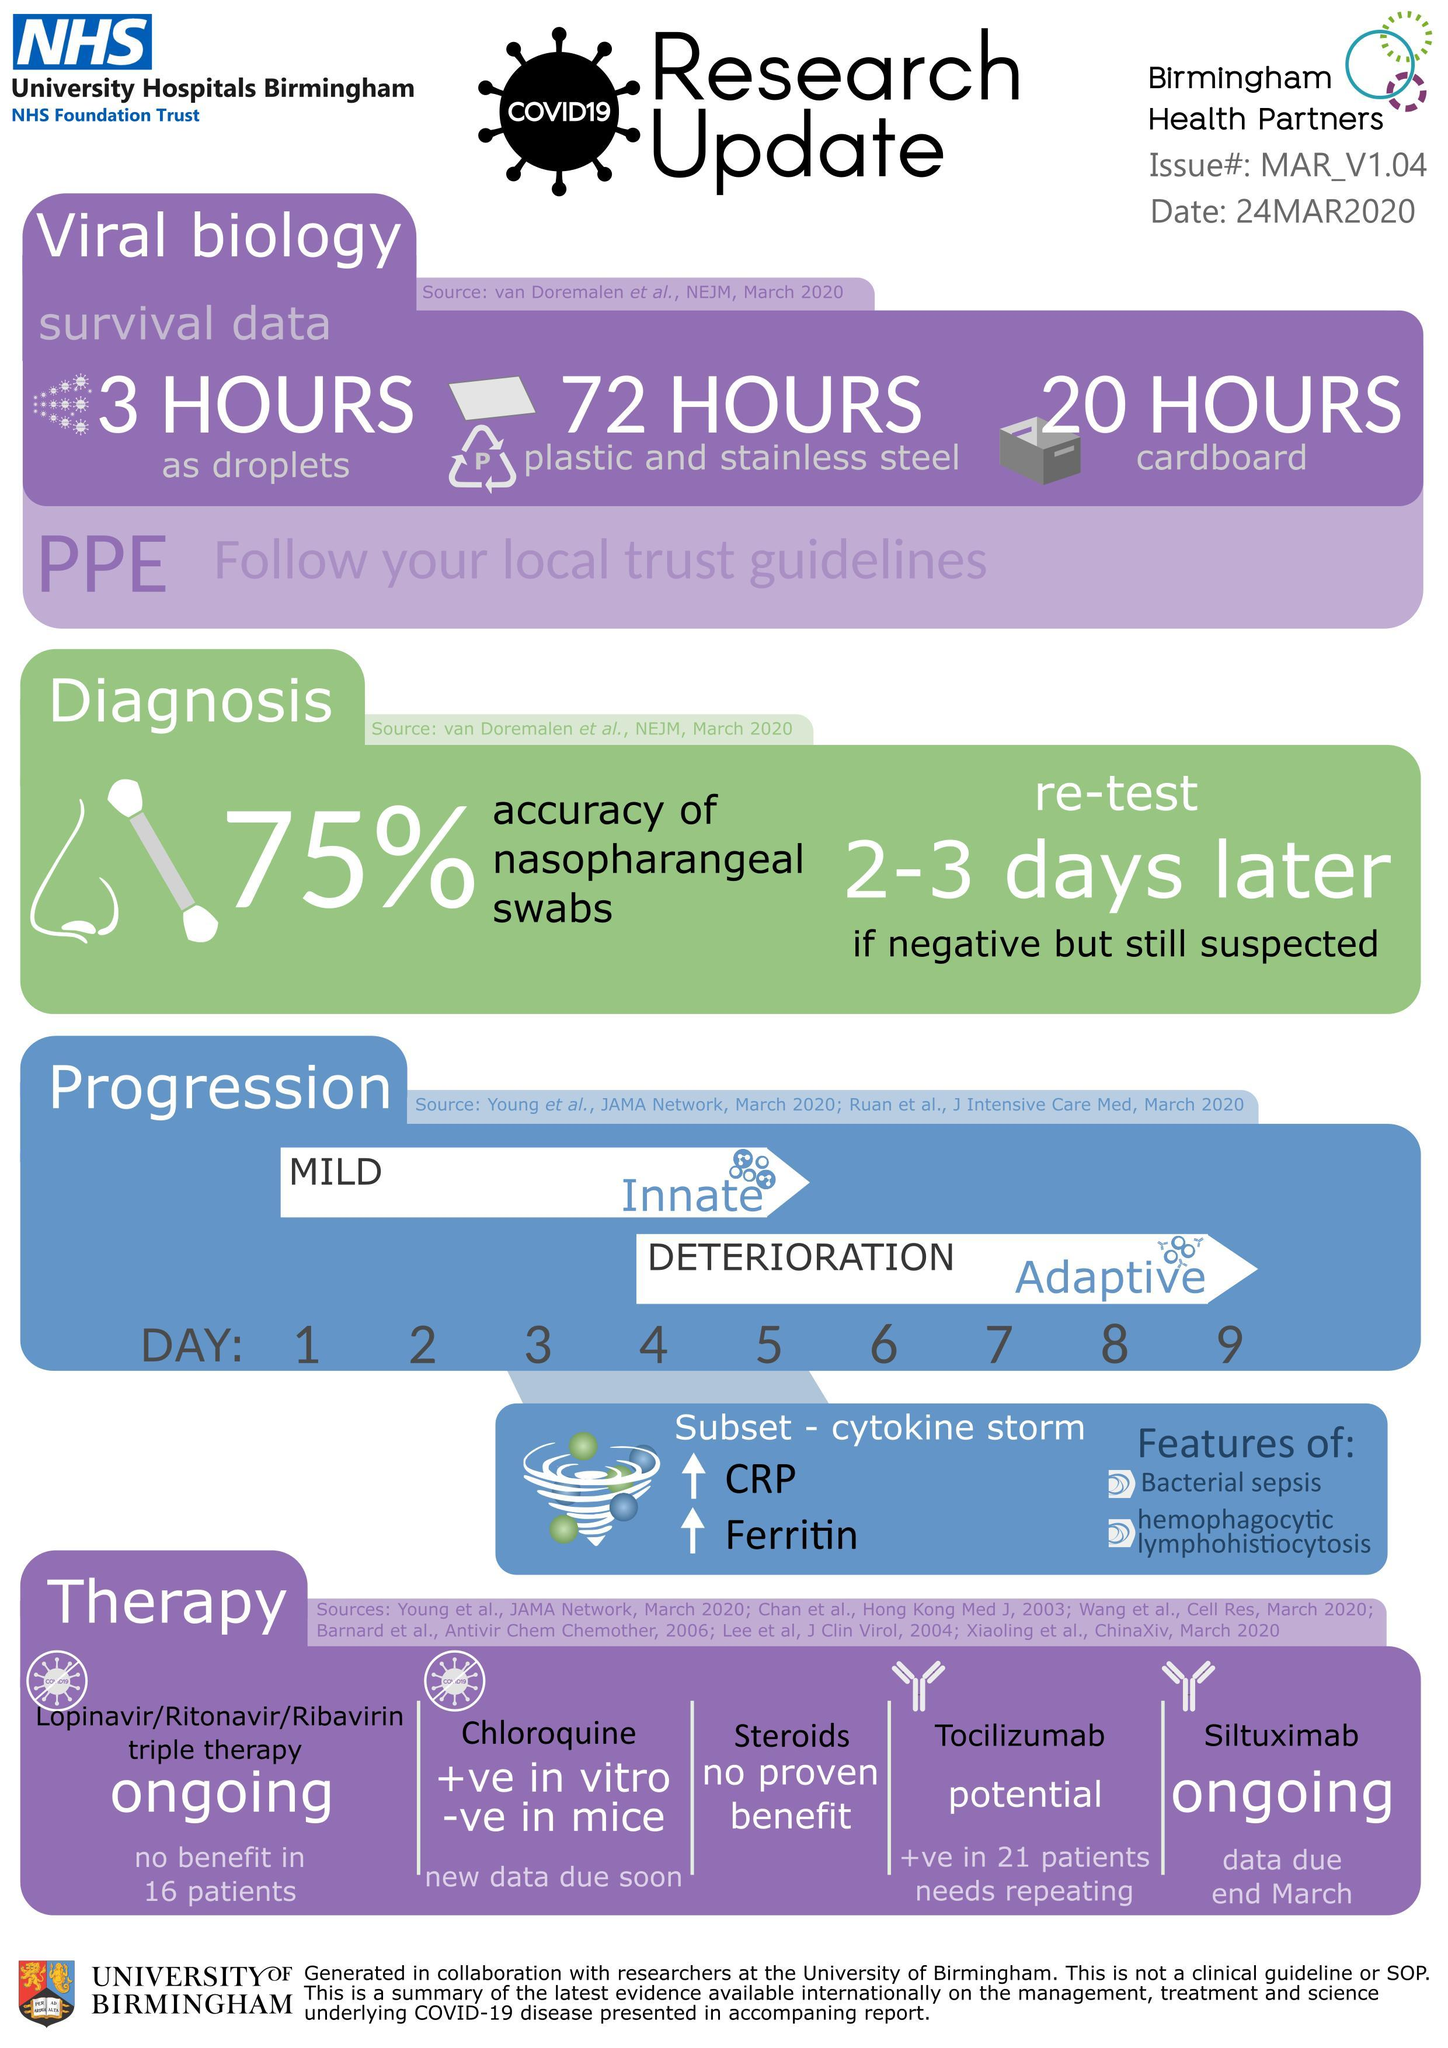What is the accuracy percentage of nasopharangeal swabs taken for the diagnosis of Covid-19?
Answer the question with a short phrase. 75% How long the Covid-19 virus can stay as droplets in the air? 3 HOURS How long the Covid-19 virus can stay on the cardboard? 20 HOURS How long the Covid-19 virus can stay on plastic & stainless steel surfaces? 72 HOURS 